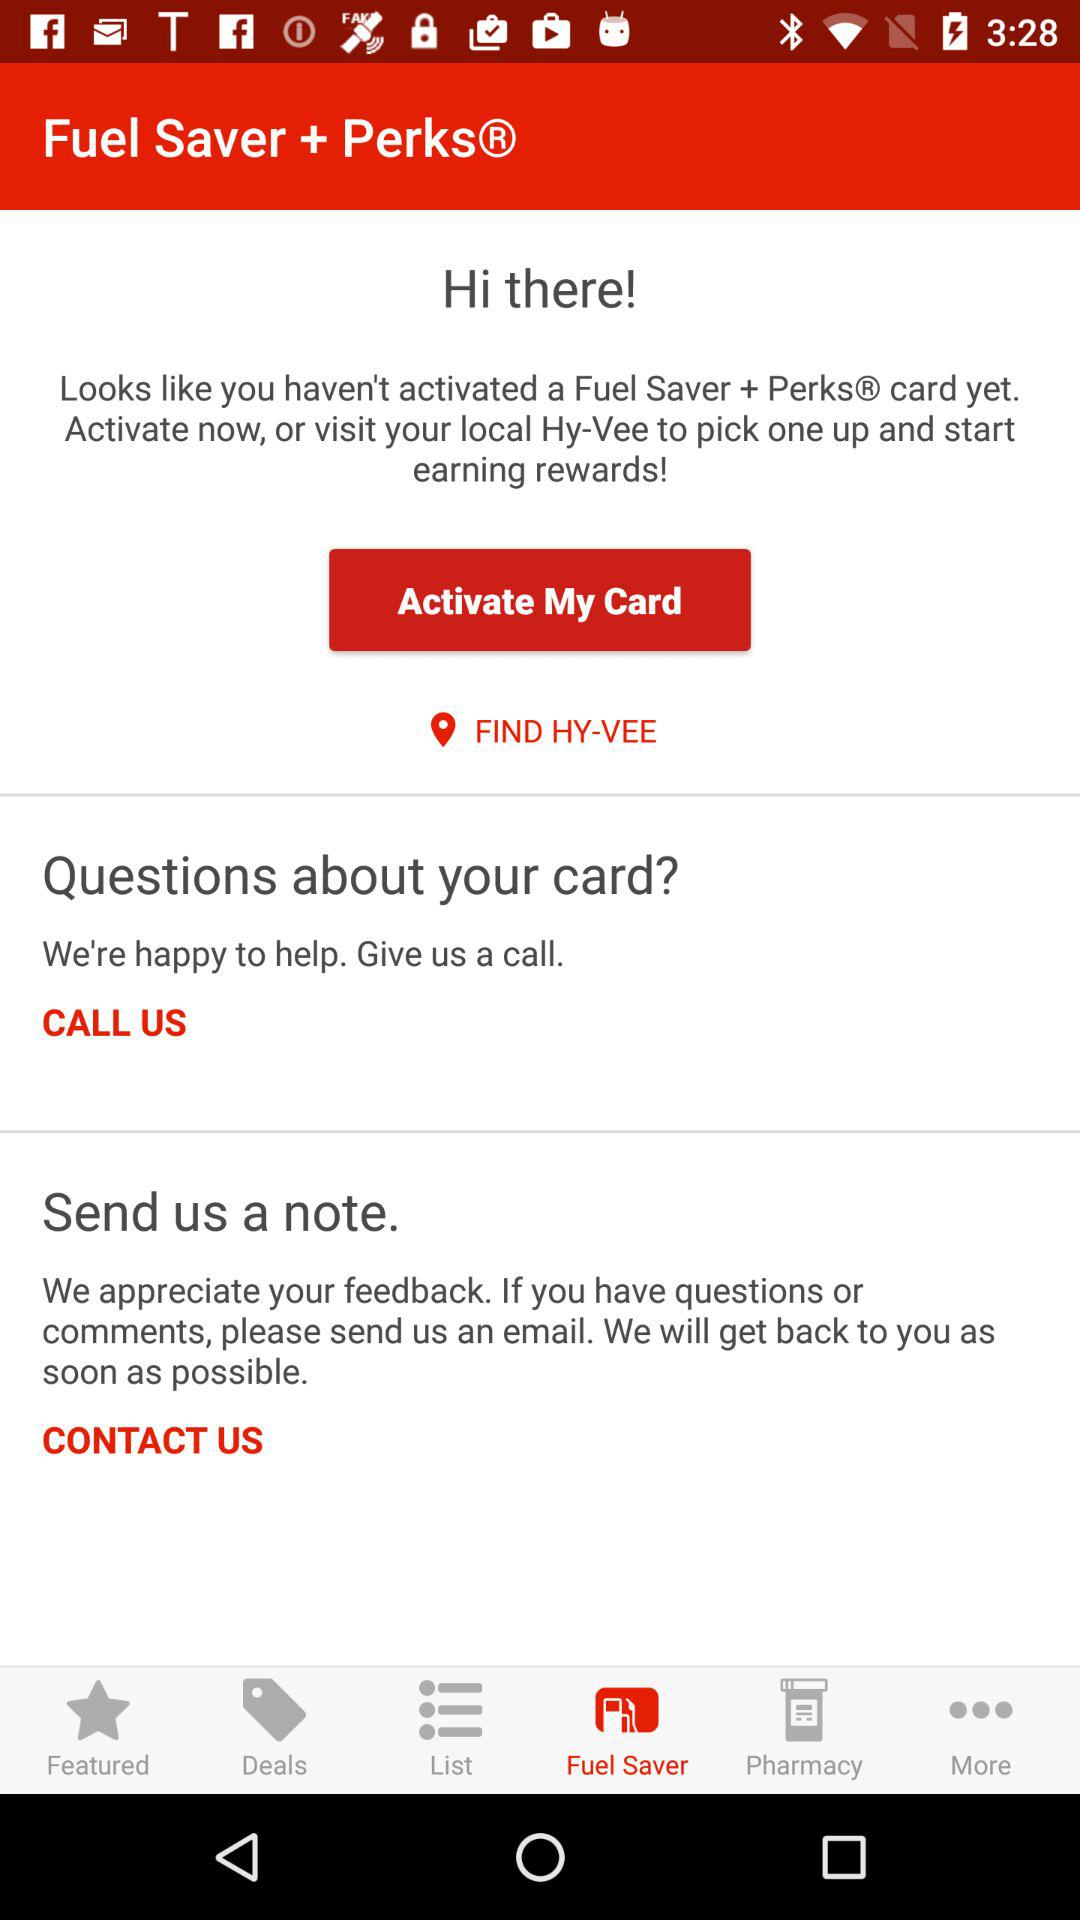What is the application name? The application name is "Hy-Vee". 